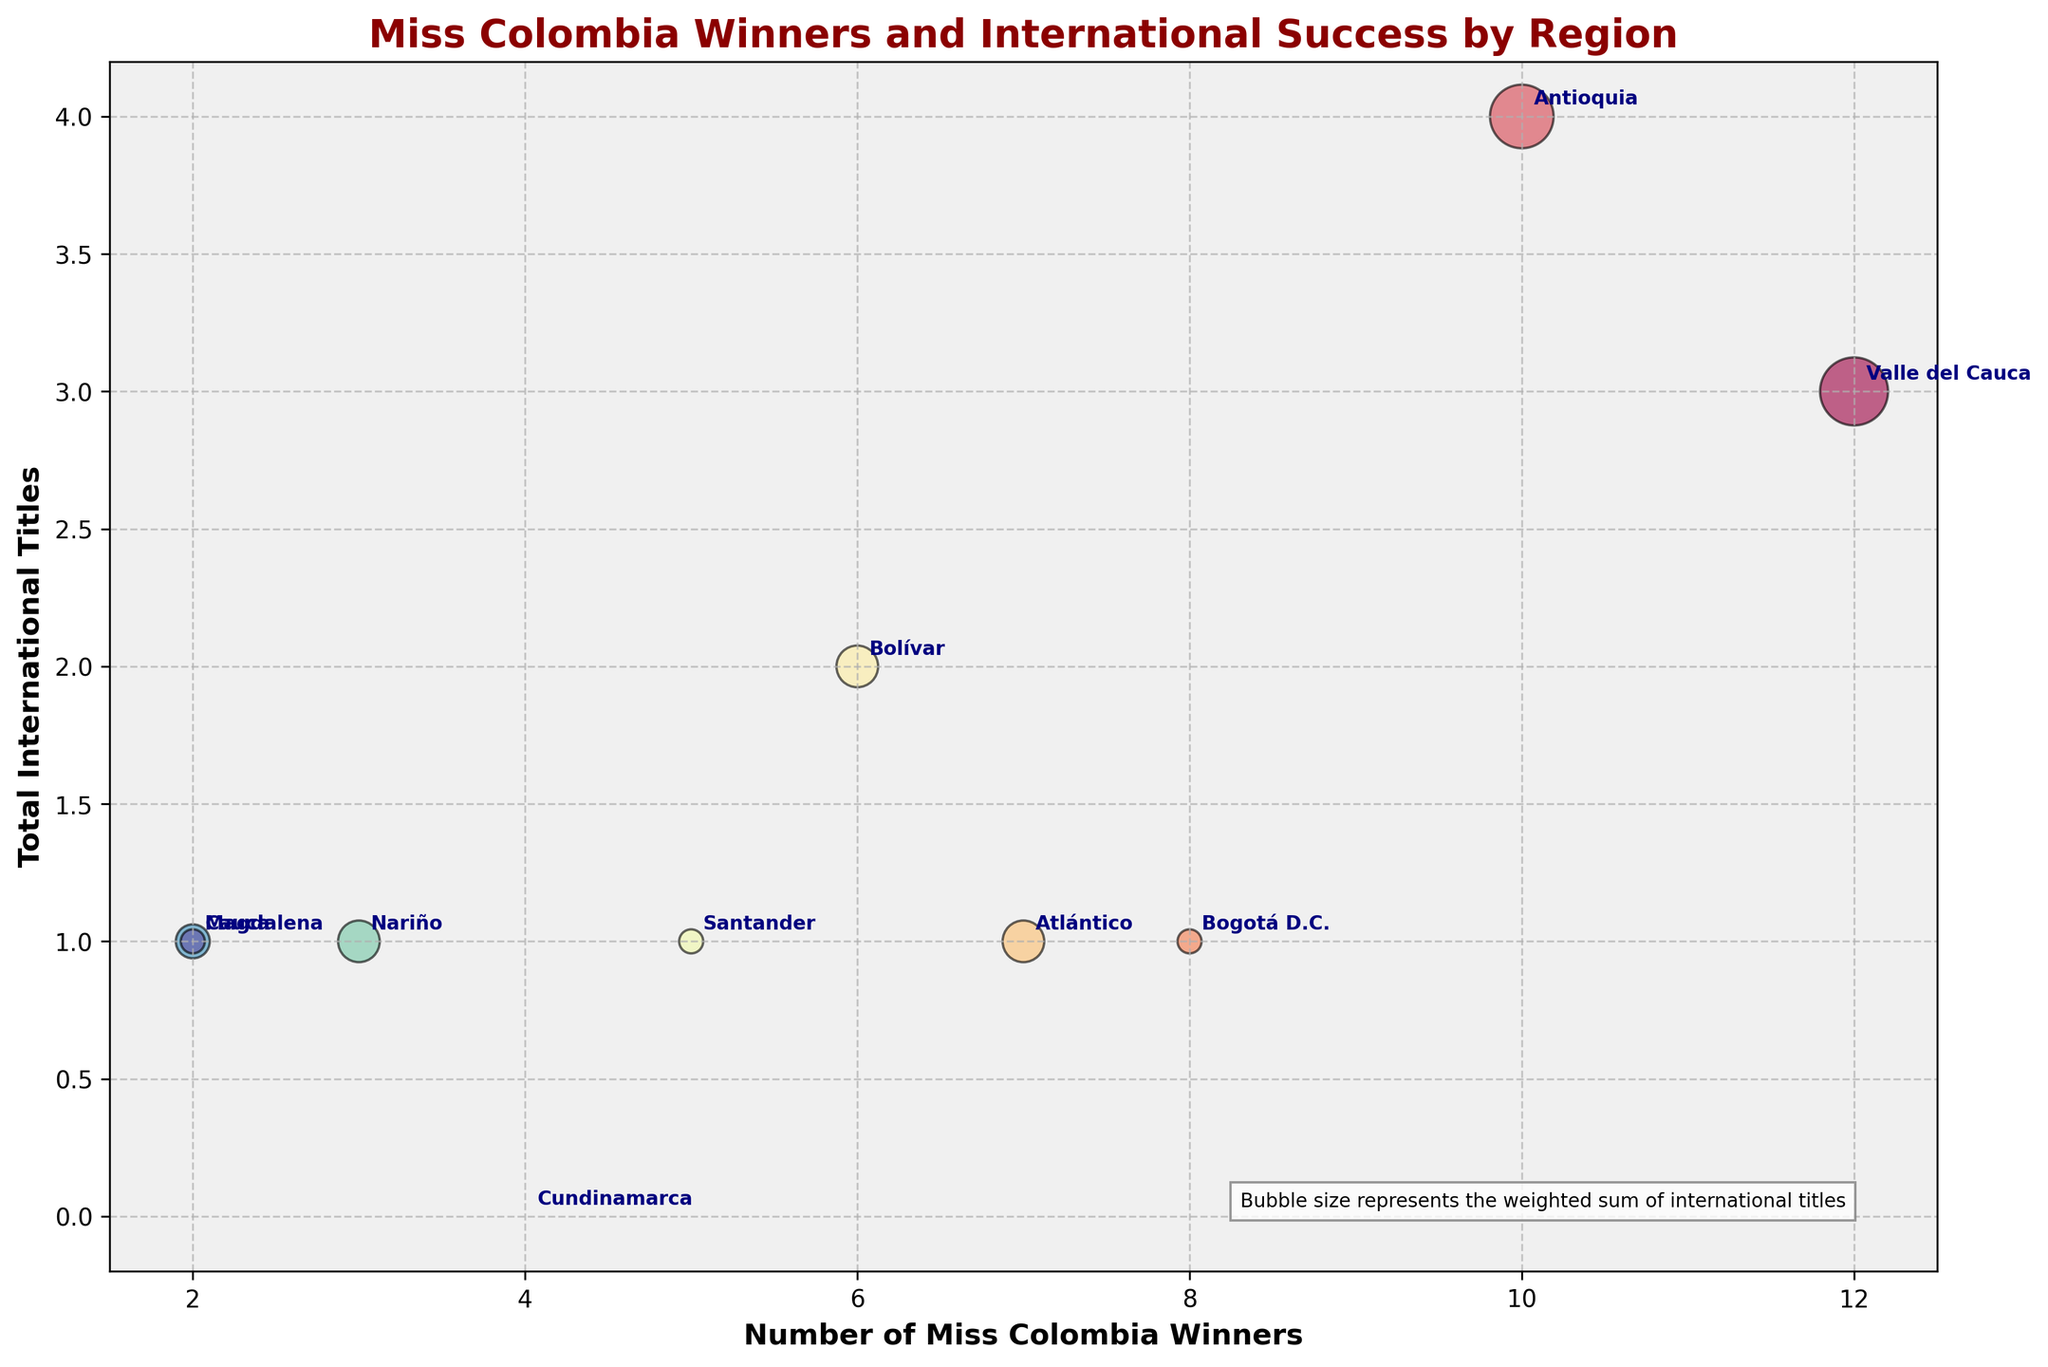Which region has the most Miss Colombia winners? The region with the highest value on the x-axis represents the most Miss Colombia winners. By inspecting the figure, we can see that Valle del Cauca has the highest number.
Answer: Valle del Cauca Which region has the highest total international titles? The region with the highest value on the y-axis represents the highest total international titles. By examining the figure, Valle del Cauca has the highest total international titles.
Answer: Valle del Cauca How many international titles has Valle del Cauca won? The y-value for Valle del Cauca represents its total international titles. The figure shows that Valle del Cauca has won a total of 3 international titles.
Answer: 3 Do more Miss Colombia winners correspond to more international titles? Examine if regions with more Miss Colombia winners (higher x-values) also have higher y-values (more international titles). Generally, regions like Valle del Cauca and Antioquia do show a trend that more Miss Colombia winners align with more international titles.
Answer: Generally, yes Which region's bubble has the largest size, and what does it represent? The size of the bubbles indicates the weighted sum of international titles won. By checking the figure, Valle del Cauca has the largest bubble. This shows it has won the most weighted international titles.
Answer: Valle del Cauca How many Miss Universe titles were won by Antioquia compared to Bogotá D.C.? To answer this, compare the specific y-values for Miss Universe titles from the data provided for Antioquia and Bogotá D.C. Antioquia has 1 Miss Universe title, while Bogotá D.C. has 0.
Answer: 1 vs 0 Do any regions have fewer Miss Colombia winners but a higher total of international titles? Compare the x-values (number of Miss Colombia winners) with y-values (total international titles). Antioquia, with 10 winners and 4 international titles, indicates that a higher total international title ratio is possible.
Answer: Antioquia Which region's bubble is smallest, and what could it signify? The smallest bubble represents the least weighted sum of international titles. By observing the figure, Cundinamarca has the smallest bubble, signifying no international titles.
Answer: Cundinamarca How does Bogotá D.C. compare to Magdalena in terms of Miss Colombia winners and total international titles? Compare the positions of Bogotá D.C. and Magdalena in the x-axis (number of Miss Colombia winners) and y-axis (total international titles). Bogotá D.C. has 8 winners and 1 international title, whereas Magdalena has 2 winners and 1 international title.
Answer: Bogotá D.C.: 8 winners, 1 title; Magdalena: 2 winners, 1 title 